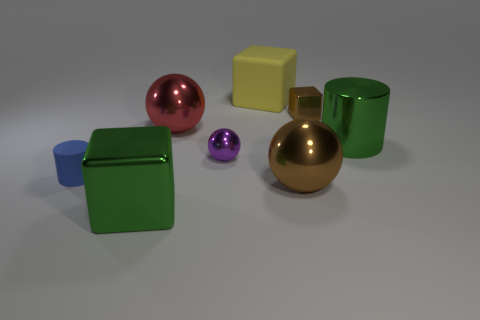The metallic thing that is the same color as the big cylinder is what size?
Your answer should be very brief. Large. There is a brown cube that is made of the same material as the big green cylinder; what size is it?
Ensure brevity in your answer.  Small. How many objects are small objects that are to the left of the big red sphere or objects on the right side of the small cylinder?
Keep it short and to the point. 8. Is the number of tiny blue things on the left side of the blue thing the same as the number of big things behind the purple shiny ball?
Your answer should be very brief. No. What is the color of the big block in front of the yellow matte cube?
Offer a terse response. Green. Is the color of the tiny ball the same as the large sphere that is in front of the green metallic cylinder?
Ensure brevity in your answer.  No. Are there fewer yellow blocks than big things?
Offer a terse response. Yes. Does the cube in front of the green cylinder have the same color as the small rubber cylinder?
Your answer should be very brief. No. How many purple objects have the same size as the green metal cylinder?
Offer a terse response. 0. Is there a rubber thing of the same color as the rubber cube?
Make the answer very short. No. 